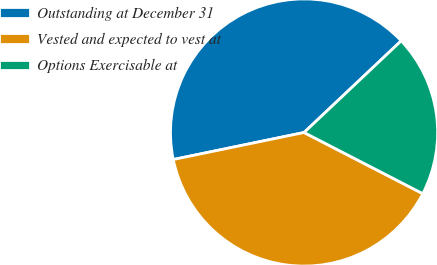Convert chart. <chart><loc_0><loc_0><loc_500><loc_500><pie_chart><fcel>Outstanding at December 31<fcel>Vested and expected to vest at<fcel>Options Exercisable at<nl><fcel>41.21%<fcel>39.19%<fcel>19.61%<nl></chart> 